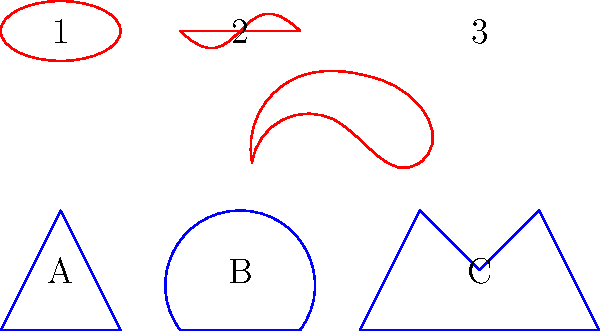In the diagram above, classic 1950s dress silhouettes (A, B, C) are paired with galaxy shapes (1, 2, 3). Which dress silhouette most closely resembles the shape of a spiral galaxy, and why? To answer this question, let's analyze each dress silhouette and galaxy shape:

1. Dress A: A-line silhouette, narrow at the waist and wider at the hem.
2. Dress B: Hourglass silhouette, fitted at the waist with a full skirt.
3. Dress C: New Look silhouette, fitted bodice with a very full skirt.

Now, let's look at the galaxy shapes:

1. Galaxy 1: Elliptical shape, representing an elliptical galaxy.
2. Galaxy 2: Bar-like structure with spiral arms, representing a barred spiral galaxy.
3. Galaxy 3: Spiral structure, representing a classic spiral galaxy.

A spiral galaxy typically has a central bulge and spiral arms extending outward. Among the dress silhouettes, Dress B (the hourglass silhouette) most closely resembles this shape. The fitted waist of Dress B can be likened to the central bulge of a spiral galaxy, while the full skirt represents the spiral arms extending outward.

Dress A doesn't have the curved structure needed to represent spiral arms, and Dress C, while fuller, doesn't have the gradual expansion that mimics spiral arms as well as Dress B does.
Answer: Dress B (hourglass silhouette) 